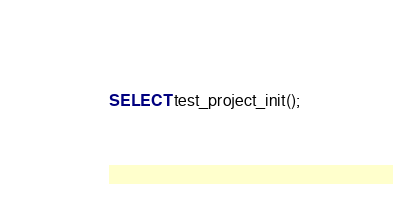Convert code to text. <code><loc_0><loc_0><loc_500><loc_500><_SQL_>SELECT test_project_init();</code> 